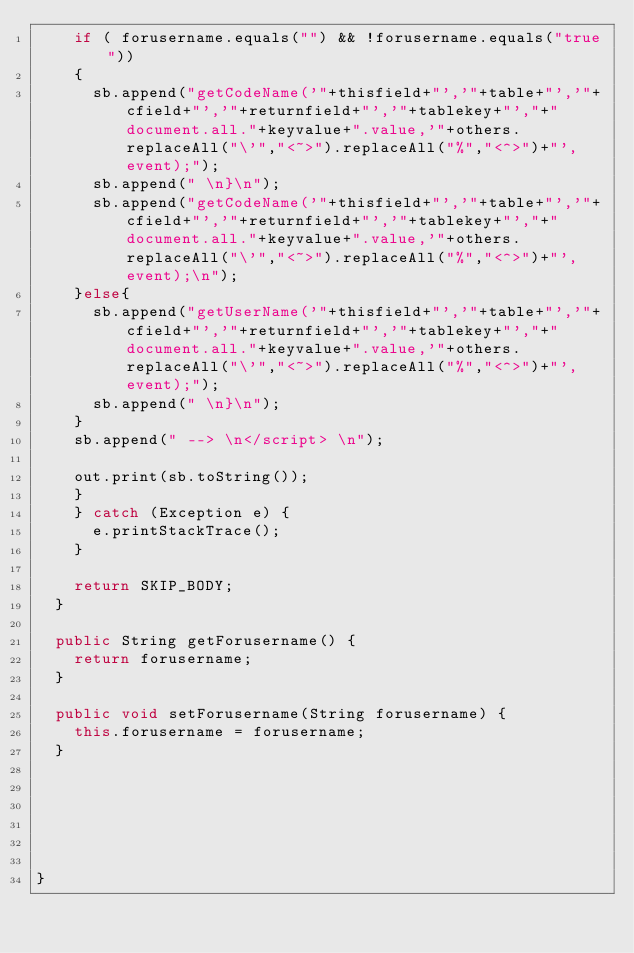<code> <loc_0><loc_0><loc_500><loc_500><_Java_>		if ( forusername.equals("") && !forusername.equals("true"))
		{
			sb.append("getCodeName('"+thisfield+"','"+table+"','"+cfield+"','"+returnfield+"','"+tablekey+"',"+"document.all."+keyvalue+".value,'"+others.replaceAll("\'","<~>").replaceAll("%","<^>")+"',event);");
			sb.append(" \n}\n");
			sb.append("getCodeName('"+thisfield+"','"+table+"','"+cfield+"','"+returnfield+"','"+tablekey+"',"+"document.all."+keyvalue+".value,'"+others.replaceAll("\'","<~>").replaceAll("%","<^>")+"',event);\n");
		}else{
			sb.append("getUserName('"+thisfield+"','"+table+"','"+cfield+"','"+returnfield+"','"+tablekey+"',"+"document.all."+keyvalue+".value,'"+others.replaceAll("\'","<~>").replaceAll("%","<^>")+"',event);");
			sb.append(" \n}\n");
		}
		sb.append(" --> \n</script> \n");
		
		out.print(sb.toString());
		}
		} catch (Exception e) {
			e.printStackTrace();
		}
		
		return SKIP_BODY;
	}

	public String getForusername() {
		return forusername;
	}

	public void setForusername(String forusername) {
		this.forusername = forusername;
	}

	
	

	
	
}
</code> 